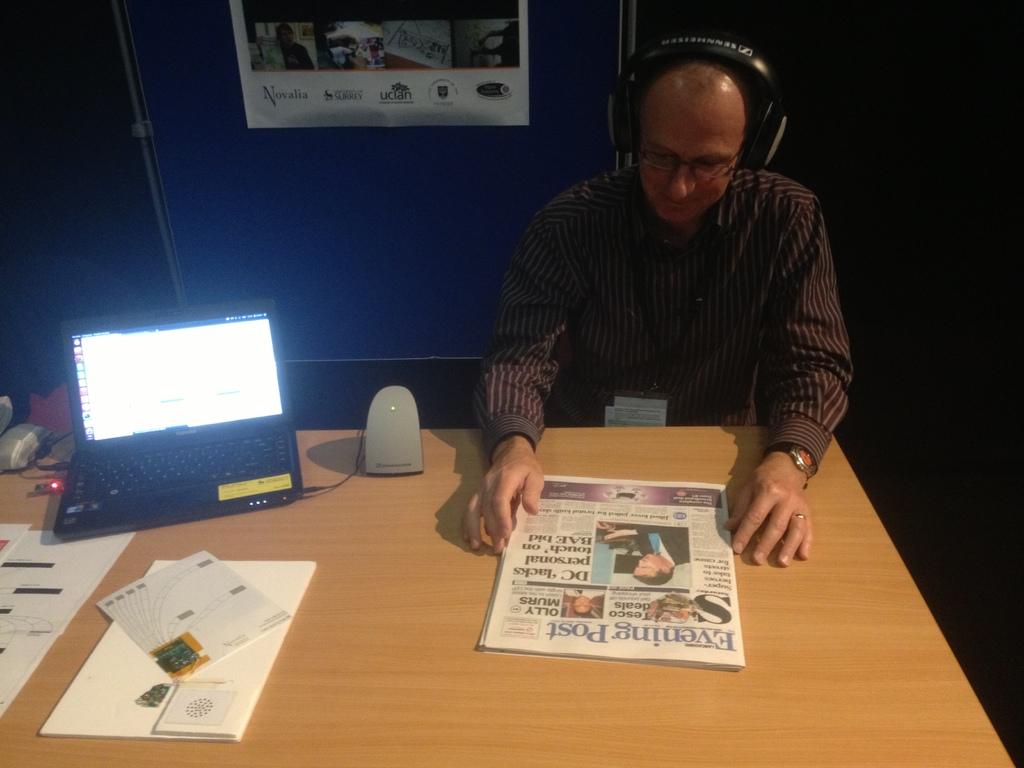What newspaper is he reading?
Make the answer very short. Evening post. 